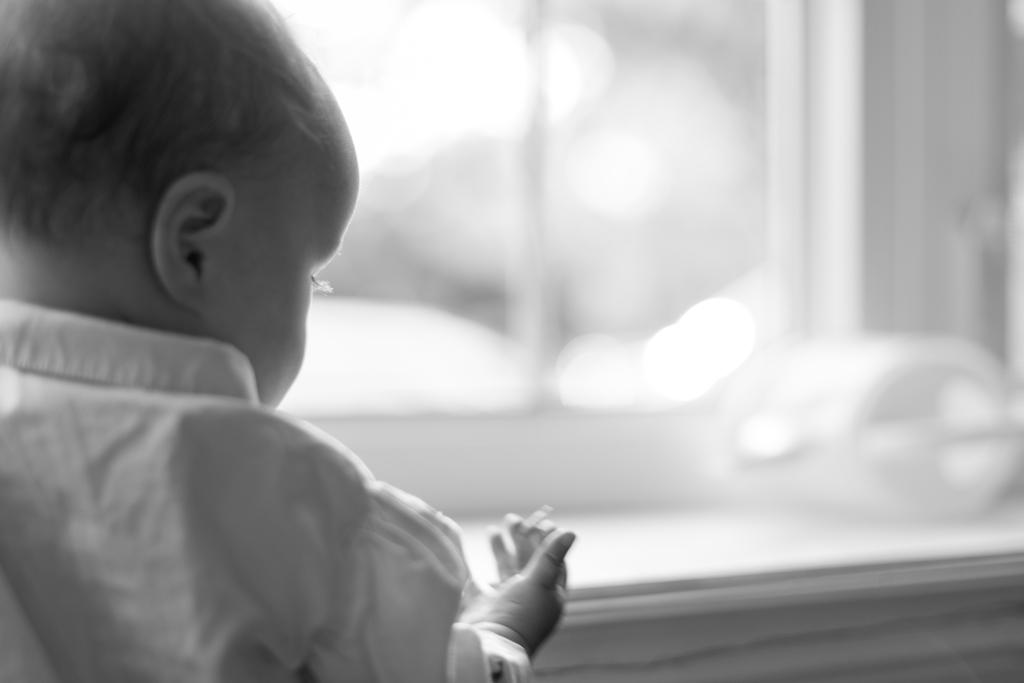What is the main subject of the image? There is a baby in the image. Where is the baby located in the image? The baby is on the left side of the image. Can you describe the background of the image? The background of the image is blurred. What is the color scheme of the image? The image is black and white. What type of mountain is visible in the background of the image? There is no mountain visible in the background of the image; it is blurred. What caption would you give to the image? It is not possible to provide a caption for the image without additional context or information. 